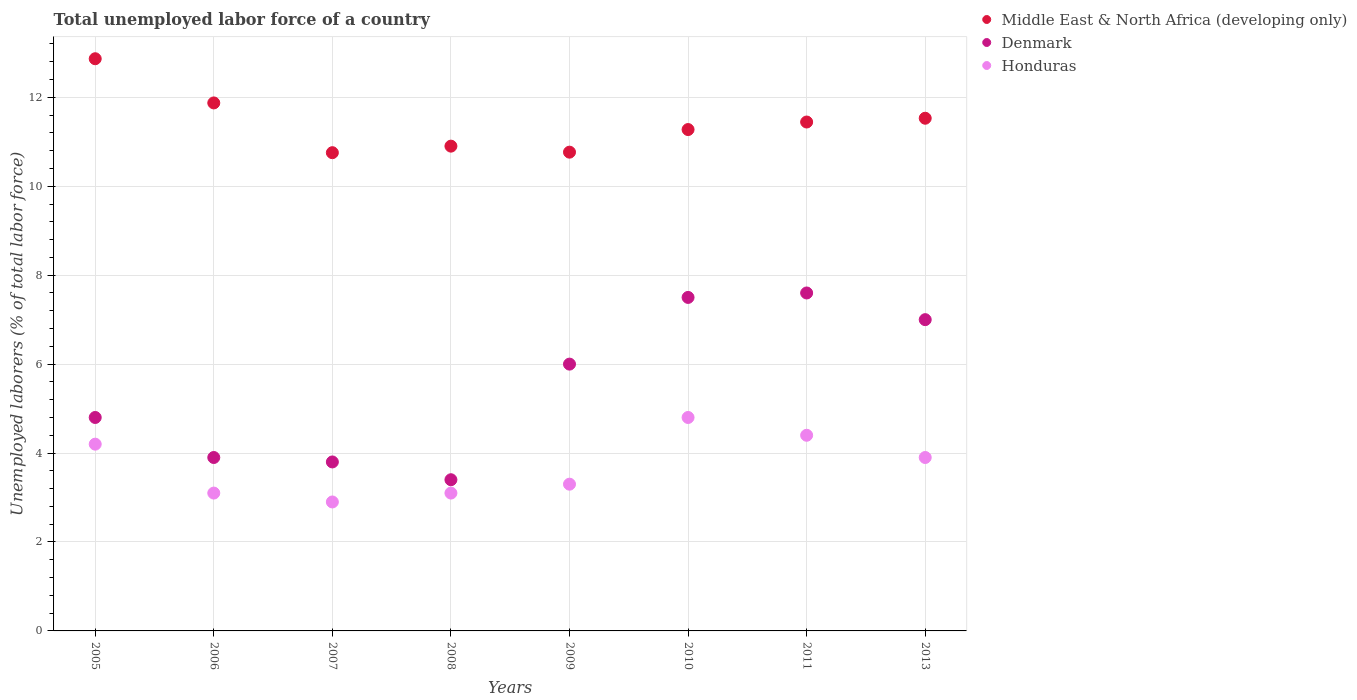What is the total unemployed labor force in Denmark in 2011?
Offer a very short reply. 7.6. Across all years, what is the maximum total unemployed labor force in Honduras?
Your answer should be very brief. 4.8. Across all years, what is the minimum total unemployed labor force in Denmark?
Your answer should be very brief. 3.4. In which year was the total unemployed labor force in Middle East & North Africa (developing only) maximum?
Keep it short and to the point. 2005. What is the total total unemployed labor force in Denmark in the graph?
Give a very brief answer. 44. What is the difference between the total unemployed labor force in Denmark in 2005 and that in 2009?
Your answer should be very brief. -1.2. What is the average total unemployed labor force in Honduras per year?
Provide a succinct answer. 3.71. In the year 2013, what is the difference between the total unemployed labor force in Middle East & North Africa (developing only) and total unemployed labor force in Honduras?
Offer a very short reply. 7.63. What is the ratio of the total unemployed labor force in Honduras in 2005 to that in 2008?
Your answer should be compact. 1.35. Is the total unemployed labor force in Middle East & North Africa (developing only) in 2007 less than that in 2011?
Provide a succinct answer. Yes. Is the difference between the total unemployed labor force in Middle East & North Africa (developing only) in 2007 and 2009 greater than the difference between the total unemployed labor force in Honduras in 2007 and 2009?
Offer a very short reply. Yes. What is the difference between the highest and the second highest total unemployed labor force in Denmark?
Offer a very short reply. 0.1. What is the difference between the highest and the lowest total unemployed labor force in Honduras?
Ensure brevity in your answer.  1.9. Is the total unemployed labor force in Honduras strictly greater than the total unemployed labor force in Middle East & North Africa (developing only) over the years?
Provide a succinct answer. No. How many years are there in the graph?
Keep it short and to the point. 8. What is the difference between two consecutive major ticks on the Y-axis?
Provide a short and direct response. 2. Does the graph contain any zero values?
Offer a very short reply. No. Does the graph contain grids?
Keep it short and to the point. Yes. Where does the legend appear in the graph?
Make the answer very short. Top right. What is the title of the graph?
Provide a short and direct response. Total unemployed labor force of a country. Does "Rwanda" appear as one of the legend labels in the graph?
Offer a very short reply. No. What is the label or title of the Y-axis?
Offer a terse response. Unemployed laborers (% of total labor force). What is the Unemployed laborers (% of total labor force) in Middle East & North Africa (developing only) in 2005?
Ensure brevity in your answer.  12.87. What is the Unemployed laborers (% of total labor force) in Denmark in 2005?
Keep it short and to the point. 4.8. What is the Unemployed laborers (% of total labor force) of Honduras in 2005?
Make the answer very short. 4.2. What is the Unemployed laborers (% of total labor force) of Middle East & North Africa (developing only) in 2006?
Offer a very short reply. 11.87. What is the Unemployed laborers (% of total labor force) of Denmark in 2006?
Provide a short and direct response. 3.9. What is the Unemployed laborers (% of total labor force) of Honduras in 2006?
Your response must be concise. 3.1. What is the Unemployed laborers (% of total labor force) in Middle East & North Africa (developing only) in 2007?
Make the answer very short. 10.75. What is the Unemployed laborers (% of total labor force) in Denmark in 2007?
Your response must be concise. 3.8. What is the Unemployed laborers (% of total labor force) in Honduras in 2007?
Your answer should be compact. 2.9. What is the Unemployed laborers (% of total labor force) of Middle East & North Africa (developing only) in 2008?
Your response must be concise. 10.9. What is the Unemployed laborers (% of total labor force) of Denmark in 2008?
Ensure brevity in your answer.  3.4. What is the Unemployed laborers (% of total labor force) of Honduras in 2008?
Your response must be concise. 3.1. What is the Unemployed laborers (% of total labor force) in Middle East & North Africa (developing only) in 2009?
Your answer should be compact. 10.77. What is the Unemployed laborers (% of total labor force) of Honduras in 2009?
Ensure brevity in your answer.  3.3. What is the Unemployed laborers (% of total labor force) of Middle East & North Africa (developing only) in 2010?
Your answer should be very brief. 11.28. What is the Unemployed laborers (% of total labor force) of Honduras in 2010?
Your answer should be compact. 4.8. What is the Unemployed laborers (% of total labor force) in Middle East & North Africa (developing only) in 2011?
Offer a terse response. 11.44. What is the Unemployed laborers (% of total labor force) of Denmark in 2011?
Provide a succinct answer. 7.6. What is the Unemployed laborers (% of total labor force) of Honduras in 2011?
Offer a terse response. 4.4. What is the Unemployed laborers (% of total labor force) of Middle East & North Africa (developing only) in 2013?
Offer a terse response. 11.53. What is the Unemployed laborers (% of total labor force) of Denmark in 2013?
Your response must be concise. 7. What is the Unemployed laborers (% of total labor force) of Honduras in 2013?
Your answer should be very brief. 3.9. Across all years, what is the maximum Unemployed laborers (% of total labor force) in Middle East & North Africa (developing only)?
Offer a very short reply. 12.87. Across all years, what is the maximum Unemployed laborers (% of total labor force) of Denmark?
Offer a terse response. 7.6. Across all years, what is the maximum Unemployed laborers (% of total labor force) in Honduras?
Your answer should be very brief. 4.8. Across all years, what is the minimum Unemployed laborers (% of total labor force) of Middle East & North Africa (developing only)?
Ensure brevity in your answer.  10.75. Across all years, what is the minimum Unemployed laborers (% of total labor force) in Denmark?
Provide a short and direct response. 3.4. Across all years, what is the minimum Unemployed laborers (% of total labor force) of Honduras?
Ensure brevity in your answer.  2.9. What is the total Unemployed laborers (% of total labor force) of Middle East & North Africa (developing only) in the graph?
Give a very brief answer. 91.41. What is the total Unemployed laborers (% of total labor force) in Honduras in the graph?
Give a very brief answer. 29.7. What is the difference between the Unemployed laborers (% of total labor force) of Middle East & North Africa (developing only) in 2005 and that in 2006?
Offer a very short reply. 0.99. What is the difference between the Unemployed laborers (% of total labor force) of Denmark in 2005 and that in 2006?
Provide a succinct answer. 0.9. What is the difference between the Unemployed laborers (% of total labor force) of Honduras in 2005 and that in 2006?
Your answer should be compact. 1.1. What is the difference between the Unemployed laborers (% of total labor force) of Middle East & North Africa (developing only) in 2005 and that in 2007?
Provide a short and direct response. 2.11. What is the difference between the Unemployed laborers (% of total labor force) in Middle East & North Africa (developing only) in 2005 and that in 2008?
Make the answer very short. 1.97. What is the difference between the Unemployed laborers (% of total labor force) in Denmark in 2005 and that in 2008?
Give a very brief answer. 1.4. What is the difference between the Unemployed laborers (% of total labor force) in Middle East & North Africa (developing only) in 2005 and that in 2009?
Ensure brevity in your answer.  2.1. What is the difference between the Unemployed laborers (% of total labor force) of Honduras in 2005 and that in 2009?
Your response must be concise. 0.9. What is the difference between the Unemployed laborers (% of total labor force) of Middle East & North Africa (developing only) in 2005 and that in 2010?
Ensure brevity in your answer.  1.59. What is the difference between the Unemployed laborers (% of total labor force) in Honduras in 2005 and that in 2010?
Your response must be concise. -0.6. What is the difference between the Unemployed laborers (% of total labor force) of Middle East & North Africa (developing only) in 2005 and that in 2011?
Keep it short and to the point. 1.42. What is the difference between the Unemployed laborers (% of total labor force) in Denmark in 2005 and that in 2011?
Offer a terse response. -2.8. What is the difference between the Unemployed laborers (% of total labor force) of Honduras in 2005 and that in 2011?
Your response must be concise. -0.2. What is the difference between the Unemployed laborers (% of total labor force) of Middle East & North Africa (developing only) in 2005 and that in 2013?
Make the answer very short. 1.34. What is the difference between the Unemployed laborers (% of total labor force) in Denmark in 2005 and that in 2013?
Keep it short and to the point. -2.2. What is the difference between the Unemployed laborers (% of total labor force) of Middle East & North Africa (developing only) in 2006 and that in 2007?
Ensure brevity in your answer.  1.12. What is the difference between the Unemployed laborers (% of total labor force) in Denmark in 2006 and that in 2007?
Make the answer very short. 0.1. What is the difference between the Unemployed laborers (% of total labor force) of Middle East & North Africa (developing only) in 2006 and that in 2008?
Offer a terse response. 0.97. What is the difference between the Unemployed laborers (% of total labor force) of Denmark in 2006 and that in 2008?
Your response must be concise. 0.5. What is the difference between the Unemployed laborers (% of total labor force) in Middle East & North Africa (developing only) in 2006 and that in 2009?
Offer a very short reply. 1.11. What is the difference between the Unemployed laborers (% of total labor force) of Middle East & North Africa (developing only) in 2006 and that in 2010?
Provide a short and direct response. 0.6. What is the difference between the Unemployed laborers (% of total labor force) of Denmark in 2006 and that in 2010?
Keep it short and to the point. -3.6. What is the difference between the Unemployed laborers (% of total labor force) in Middle East & North Africa (developing only) in 2006 and that in 2011?
Your answer should be compact. 0.43. What is the difference between the Unemployed laborers (% of total labor force) of Honduras in 2006 and that in 2011?
Keep it short and to the point. -1.3. What is the difference between the Unemployed laborers (% of total labor force) in Middle East & North Africa (developing only) in 2006 and that in 2013?
Your response must be concise. 0.34. What is the difference between the Unemployed laborers (% of total labor force) of Denmark in 2006 and that in 2013?
Ensure brevity in your answer.  -3.1. What is the difference between the Unemployed laborers (% of total labor force) in Honduras in 2006 and that in 2013?
Your answer should be very brief. -0.8. What is the difference between the Unemployed laborers (% of total labor force) of Middle East & North Africa (developing only) in 2007 and that in 2008?
Offer a very short reply. -0.15. What is the difference between the Unemployed laborers (% of total labor force) in Middle East & North Africa (developing only) in 2007 and that in 2009?
Give a very brief answer. -0.01. What is the difference between the Unemployed laborers (% of total labor force) in Denmark in 2007 and that in 2009?
Provide a succinct answer. -2.2. What is the difference between the Unemployed laborers (% of total labor force) of Honduras in 2007 and that in 2009?
Your answer should be very brief. -0.4. What is the difference between the Unemployed laborers (% of total labor force) of Middle East & North Africa (developing only) in 2007 and that in 2010?
Provide a succinct answer. -0.52. What is the difference between the Unemployed laborers (% of total labor force) in Denmark in 2007 and that in 2010?
Ensure brevity in your answer.  -3.7. What is the difference between the Unemployed laborers (% of total labor force) in Honduras in 2007 and that in 2010?
Make the answer very short. -1.9. What is the difference between the Unemployed laborers (% of total labor force) in Middle East & North Africa (developing only) in 2007 and that in 2011?
Offer a very short reply. -0.69. What is the difference between the Unemployed laborers (% of total labor force) in Denmark in 2007 and that in 2011?
Keep it short and to the point. -3.8. What is the difference between the Unemployed laborers (% of total labor force) of Middle East & North Africa (developing only) in 2007 and that in 2013?
Give a very brief answer. -0.77. What is the difference between the Unemployed laborers (% of total labor force) of Denmark in 2007 and that in 2013?
Offer a terse response. -3.2. What is the difference between the Unemployed laborers (% of total labor force) of Middle East & North Africa (developing only) in 2008 and that in 2009?
Keep it short and to the point. 0.14. What is the difference between the Unemployed laborers (% of total labor force) of Denmark in 2008 and that in 2009?
Provide a succinct answer. -2.6. What is the difference between the Unemployed laborers (% of total labor force) in Middle East & North Africa (developing only) in 2008 and that in 2010?
Offer a very short reply. -0.37. What is the difference between the Unemployed laborers (% of total labor force) in Honduras in 2008 and that in 2010?
Keep it short and to the point. -1.7. What is the difference between the Unemployed laborers (% of total labor force) of Middle East & North Africa (developing only) in 2008 and that in 2011?
Give a very brief answer. -0.54. What is the difference between the Unemployed laborers (% of total labor force) of Middle East & North Africa (developing only) in 2008 and that in 2013?
Provide a short and direct response. -0.63. What is the difference between the Unemployed laborers (% of total labor force) in Honduras in 2008 and that in 2013?
Your answer should be very brief. -0.8. What is the difference between the Unemployed laborers (% of total labor force) in Middle East & North Africa (developing only) in 2009 and that in 2010?
Offer a terse response. -0.51. What is the difference between the Unemployed laborers (% of total labor force) in Honduras in 2009 and that in 2010?
Offer a very short reply. -1.5. What is the difference between the Unemployed laborers (% of total labor force) of Middle East & North Africa (developing only) in 2009 and that in 2011?
Your response must be concise. -0.68. What is the difference between the Unemployed laborers (% of total labor force) of Honduras in 2009 and that in 2011?
Your answer should be compact. -1.1. What is the difference between the Unemployed laborers (% of total labor force) of Middle East & North Africa (developing only) in 2009 and that in 2013?
Offer a terse response. -0.76. What is the difference between the Unemployed laborers (% of total labor force) of Denmark in 2009 and that in 2013?
Your answer should be very brief. -1. What is the difference between the Unemployed laborers (% of total labor force) in Middle East & North Africa (developing only) in 2010 and that in 2011?
Give a very brief answer. -0.17. What is the difference between the Unemployed laborers (% of total labor force) of Middle East & North Africa (developing only) in 2010 and that in 2013?
Give a very brief answer. -0.25. What is the difference between the Unemployed laborers (% of total labor force) of Middle East & North Africa (developing only) in 2011 and that in 2013?
Your answer should be compact. -0.09. What is the difference between the Unemployed laborers (% of total labor force) of Middle East & North Africa (developing only) in 2005 and the Unemployed laborers (% of total labor force) of Denmark in 2006?
Your response must be concise. 8.97. What is the difference between the Unemployed laborers (% of total labor force) of Middle East & North Africa (developing only) in 2005 and the Unemployed laborers (% of total labor force) of Honduras in 2006?
Offer a very short reply. 9.77. What is the difference between the Unemployed laborers (% of total labor force) of Middle East & North Africa (developing only) in 2005 and the Unemployed laborers (% of total labor force) of Denmark in 2007?
Provide a succinct answer. 9.07. What is the difference between the Unemployed laborers (% of total labor force) of Middle East & North Africa (developing only) in 2005 and the Unemployed laborers (% of total labor force) of Honduras in 2007?
Offer a very short reply. 9.97. What is the difference between the Unemployed laborers (% of total labor force) of Middle East & North Africa (developing only) in 2005 and the Unemployed laborers (% of total labor force) of Denmark in 2008?
Offer a very short reply. 9.47. What is the difference between the Unemployed laborers (% of total labor force) in Middle East & North Africa (developing only) in 2005 and the Unemployed laborers (% of total labor force) in Honduras in 2008?
Offer a terse response. 9.77. What is the difference between the Unemployed laborers (% of total labor force) of Denmark in 2005 and the Unemployed laborers (% of total labor force) of Honduras in 2008?
Your answer should be compact. 1.7. What is the difference between the Unemployed laborers (% of total labor force) of Middle East & North Africa (developing only) in 2005 and the Unemployed laborers (% of total labor force) of Denmark in 2009?
Your answer should be very brief. 6.87. What is the difference between the Unemployed laborers (% of total labor force) in Middle East & North Africa (developing only) in 2005 and the Unemployed laborers (% of total labor force) in Honduras in 2009?
Give a very brief answer. 9.57. What is the difference between the Unemployed laborers (% of total labor force) in Denmark in 2005 and the Unemployed laborers (% of total labor force) in Honduras in 2009?
Your answer should be compact. 1.5. What is the difference between the Unemployed laborers (% of total labor force) of Middle East & North Africa (developing only) in 2005 and the Unemployed laborers (% of total labor force) of Denmark in 2010?
Give a very brief answer. 5.37. What is the difference between the Unemployed laborers (% of total labor force) in Middle East & North Africa (developing only) in 2005 and the Unemployed laborers (% of total labor force) in Honduras in 2010?
Provide a short and direct response. 8.07. What is the difference between the Unemployed laborers (% of total labor force) of Middle East & North Africa (developing only) in 2005 and the Unemployed laborers (% of total labor force) of Denmark in 2011?
Your answer should be very brief. 5.27. What is the difference between the Unemployed laborers (% of total labor force) of Middle East & North Africa (developing only) in 2005 and the Unemployed laborers (% of total labor force) of Honduras in 2011?
Keep it short and to the point. 8.47. What is the difference between the Unemployed laborers (% of total labor force) in Middle East & North Africa (developing only) in 2005 and the Unemployed laborers (% of total labor force) in Denmark in 2013?
Make the answer very short. 5.87. What is the difference between the Unemployed laborers (% of total labor force) in Middle East & North Africa (developing only) in 2005 and the Unemployed laborers (% of total labor force) in Honduras in 2013?
Your answer should be compact. 8.97. What is the difference between the Unemployed laborers (% of total labor force) of Denmark in 2005 and the Unemployed laborers (% of total labor force) of Honduras in 2013?
Keep it short and to the point. 0.9. What is the difference between the Unemployed laborers (% of total labor force) in Middle East & North Africa (developing only) in 2006 and the Unemployed laborers (% of total labor force) in Denmark in 2007?
Provide a short and direct response. 8.07. What is the difference between the Unemployed laborers (% of total labor force) in Middle East & North Africa (developing only) in 2006 and the Unemployed laborers (% of total labor force) in Honduras in 2007?
Your response must be concise. 8.97. What is the difference between the Unemployed laborers (% of total labor force) of Denmark in 2006 and the Unemployed laborers (% of total labor force) of Honduras in 2007?
Provide a succinct answer. 1. What is the difference between the Unemployed laborers (% of total labor force) of Middle East & North Africa (developing only) in 2006 and the Unemployed laborers (% of total labor force) of Denmark in 2008?
Provide a succinct answer. 8.47. What is the difference between the Unemployed laborers (% of total labor force) in Middle East & North Africa (developing only) in 2006 and the Unemployed laborers (% of total labor force) in Honduras in 2008?
Make the answer very short. 8.77. What is the difference between the Unemployed laborers (% of total labor force) in Denmark in 2006 and the Unemployed laborers (% of total labor force) in Honduras in 2008?
Ensure brevity in your answer.  0.8. What is the difference between the Unemployed laborers (% of total labor force) in Middle East & North Africa (developing only) in 2006 and the Unemployed laborers (% of total labor force) in Denmark in 2009?
Keep it short and to the point. 5.87. What is the difference between the Unemployed laborers (% of total labor force) of Middle East & North Africa (developing only) in 2006 and the Unemployed laborers (% of total labor force) of Honduras in 2009?
Your answer should be very brief. 8.57. What is the difference between the Unemployed laborers (% of total labor force) of Denmark in 2006 and the Unemployed laborers (% of total labor force) of Honduras in 2009?
Give a very brief answer. 0.6. What is the difference between the Unemployed laborers (% of total labor force) in Middle East & North Africa (developing only) in 2006 and the Unemployed laborers (% of total labor force) in Denmark in 2010?
Ensure brevity in your answer.  4.37. What is the difference between the Unemployed laborers (% of total labor force) of Middle East & North Africa (developing only) in 2006 and the Unemployed laborers (% of total labor force) of Honduras in 2010?
Keep it short and to the point. 7.07. What is the difference between the Unemployed laborers (% of total labor force) of Denmark in 2006 and the Unemployed laborers (% of total labor force) of Honduras in 2010?
Ensure brevity in your answer.  -0.9. What is the difference between the Unemployed laborers (% of total labor force) in Middle East & North Africa (developing only) in 2006 and the Unemployed laborers (% of total labor force) in Denmark in 2011?
Your answer should be very brief. 4.27. What is the difference between the Unemployed laborers (% of total labor force) of Middle East & North Africa (developing only) in 2006 and the Unemployed laborers (% of total labor force) of Honduras in 2011?
Keep it short and to the point. 7.47. What is the difference between the Unemployed laborers (% of total labor force) in Denmark in 2006 and the Unemployed laborers (% of total labor force) in Honduras in 2011?
Make the answer very short. -0.5. What is the difference between the Unemployed laborers (% of total labor force) in Middle East & North Africa (developing only) in 2006 and the Unemployed laborers (% of total labor force) in Denmark in 2013?
Ensure brevity in your answer.  4.87. What is the difference between the Unemployed laborers (% of total labor force) in Middle East & North Africa (developing only) in 2006 and the Unemployed laborers (% of total labor force) in Honduras in 2013?
Your response must be concise. 7.97. What is the difference between the Unemployed laborers (% of total labor force) of Denmark in 2006 and the Unemployed laborers (% of total labor force) of Honduras in 2013?
Keep it short and to the point. 0. What is the difference between the Unemployed laborers (% of total labor force) in Middle East & North Africa (developing only) in 2007 and the Unemployed laborers (% of total labor force) in Denmark in 2008?
Provide a succinct answer. 7.35. What is the difference between the Unemployed laborers (% of total labor force) in Middle East & North Africa (developing only) in 2007 and the Unemployed laborers (% of total labor force) in Honduras in 2008?
Make the answer very short. 7.65. What is the difference between the Unemployed laborers (% of total labor force) in Denmark in 2007 and the Unemployed laborers (% of total labor force) in Honduras in 2008?
Ensure brevity in your answer.  0.7. What is the difference between the Unemployed laborers (% of total labor force) of Middle East & North Africa (developing only) in 2007 and the Unemployed laborers (% of total labor force) of Denmark in 2009?
Your answer should be very brief. 4.75. What is the difference between the Unemployed laborers (% of total labor force) of Middle East & North Africa (developing only) in 2007 and the Unemployed laborers (% of total labor force) of Honduras in 2009?
Your response must be concise. 7.45. What is the difference between the Unemployed laborers (% of total labor force) of Denmark in 2007 and the Unemployed laborers (% of total labor force) of Honduras in 2009?
Offer a very short reply. 0.5. What is the difference between the Unemployed laborers (% of total labor force) of Middle East & North Africa (developing only) in 2007 and the Unemployed laborers (% of total labor force) of Denmark in 2010?
Provide a short and direct response. 3.25. What is the difference between the Unemployed laborers (% of total labor force) in Middle East & North Africa (developing only) in 2007 and the Unemployed laborers (% of total labor force) in Honduras in 2010?
Give a very brief answer. 5.95. What is the difference between the Unemployed laborers (% of total labor force) in Denmark in 2007 and the Unemployed laborers (% of total labor force) in Honduras in 2010?
Your answer should be compact. -1. What is the difference between the Unemployed laborers (% of total labor force) of Middle East & North Africa (developing only) in 2007 and the Unemployed laborers (% of total labor force) of Denmark in 2011?
Your answer should be very brief. 3.15. What is the difference between the Unemployed laborers (% of total labor force) in Middle East & North Africa (developing only) in 2007 and the Unemployed laborers (% of total labor force) in Honduras in 2011?
Keep it short and to the point. 6.35. What is the difference between the Unemployed laborers (% of total labor force) in Denmark in 2007 and the Unemployed laborers (% of total labor force) in Honduras in 2011?
Offer a terse response. -0.6. What is the difference between the Unemployed laborers (% of total labor force) in Middle East & North Africa (developing only) in 2007 and the Unemployed laborers (% of total labor force) in Denmark in 2013?
Your answer should be compact. 3.75. What is the difference between the Unemployed laborers (% of total labor force) in Middle East & North Africa (developing only) in 2007 and the Unemployed laborers (% of total labor force) in Honduras in 2013?
Provide a short and direct response. 6.85. What is the difference between the Unemployed laborers (% of total labor force) in Middle East & North Africa (developing only) in 2008 and the Unemployed laborers (% of total labor force) in Denmark in 2009?
Your answer should be very brief. 4.9. What is the difference between the Unemployed laborers (% of total labor force) in Middle East & North Africa (developing only) in 2008 and the Unemployed laborers (% of total labor force) in Honduras in 2009?
Offer a very short reply. 7.6. What is the difference between the Unemployed laborers (% of total labor force) in Middle East & North Africa (developing only) in 2008 and the Unemployed laborers (% of total labor force) in Denmark in 2010?
Make the answer very short. 3.4. What is the difference between the Unemployed laborers (% of total labor force) in Middle East & North Africa (developing only) in 2008 and the Unemployed laborers (% of total labor force) in Honduras in 2010?
Your answer should be compact. 6.1. What is the difference between the Unemployed laborers (% of total labor force) in Denmark in 2008 and the Unemployed laborers (% of total labor force) in Honduras in 2010?
Offer a very short reply. -1.4. What is the difference between the Unemployed laborers (% of total labor force) in Middle East & North Africa (developing only) in 2008 and the Unemployed laborers (% of total labor force) in Denmark in 2011?
Your answer should be very brief. 3.3. What is the difference between the Unemployed laborers (% of total labor force) in Middle East & North Africa (developing only) in 2008 and the Unemployed laborers (% of total labor force) in Honduras in 2011?
Give a very brief answer. 6.5. What is the difference between the Unemployed laborers (% of total labor force) of Middle East & North Africa (developing only) in 2008 and the Unemployed laborers (% of total labor force) of Denmark in 2013?
Offer a very short reply. 3.9. What is the difference between the Unemployed laborers (% of total labor force) of Middle East & North Africa (developing only) in 2008 and the Unemployed laborers (% of total labor force) of Honduras in 2013?
Offer a very short reply. 7. What is the difference between the Unemployed laborers (% of total labor force) of Denmark in 2008 and the Unemployed laborers (% of total labor force) of Honduras in 2013?
Your response must be concise. -0.5. What is the difference between the Unemployed laborers (% of total labor force) of Middle East & North Africa (developing only) in 2009 and the Unemployed laborers (% of total labor force) of Denmark in 2010?
Offer a very short reply. 3.27. What is the difference between the Unemployed laborers (% of total labor force) in Middle East & North Africa (developing only) in 2009 and the Unemployed laborers (% of total labor force) in Honduras in 2010?
Your response must be concise. 5.97. What is the difference between the Unemployed laborers (% of total labor force) in Denmark in 2009 and the Unemployed laborers (% of total labor force) in Honduras in 2010?
Keep it short and to the point. 1.2. What is the difference between the Unemployed laborers (% of total labor force) of Middle East & North Africa (developing only) in 2009 and the Unemployed laborers (% of total labor force) of Denmark in 2011?
Give a very brief answer. 3.17. What is the difference between the Unemployed laborers (% of total labor force) of Middle East & North Africa (developing only) in 2009 and the Unemployed laborers (% of total labor force) of Honduras in 2011?
Provide a succinct answer. 6.37. What is the difference between the Unemployed laborers (% of total labor force) of Middle East & North Africa (developing only) in 2009 and the Unemployed laborers (% of total labor force) of Denmark in 2013?
Make the answer very short. 3.77. What is the difference between the Unemployed laborers (% of total labor force) in Middle East & North Africa (developing only) in 2009 and the Unemployed laborers (% of total labor force) in Honduras in 2013?
Your answer should be compact. 6.87. What is the difference between the Unemployed laborers (% of total labor force) of Middle East & North Africa (developing only) in 2010 and the Unemployed laborers (% of total labor force) of Denmark in 2011?
Make the answer very short. 3.68. What is the difference between the Unemployed laborers (% of total labor force) of Middle East & North Africa (developing only) in 2010 and the Unemployed laborers (% of total labor force) of Honduras in 2011?
Provide a succinct answer. 6.88. What is the difference between the Unemployed laborers (% of total labor force) in Denmark in 2010 and the Unemployed laborers (% of total labor force) in Honduras in 2011?
Offer a terse response. 3.1. What is the difference between the Unemployed laborers (% of total labor force) of Middle East & North Africa (developing only) in 2010 and the Unemployed laborers (% of total labor force) of Denmark in 2013?
Keep it short and to the point. 4.28. What is the difference between the Unemployed laborers (% of total labor force) of Middle East & North Africa (developing only) in 2010 and the Unemployed laborers (% of total labor force) of Honduras in 2013?
Give a very brief answer. 7.38. What is the difference between the Unemployed laborers (% of total labor force) of Middle East & North Africa (developing only) in 2011 and the Unemployed laborers (% of total labor force) of Denmark in 2013?
Keep it short and to the point. 4.44. What is the difference between the Unemployed laborers (% of total labor force) in Middle East & North Africa (developing only) in 2011 and the Unemployed laborers (% of total labor force) in Honduras in 2013?
Give a very brief answer. 7.54. What is the average Unemployed laborers (% of total labor force) of Middle East & North Africa (developing only) per year?
Your answer should be compact. 11.43. What is the average Unemployed laborers (% of total labor force) of Denmark per year?
Give a very brief answer. 5.5. What is the average Unemployed laborers (% of total labor force) of Honduras per year?
Provide a succinct answer. 3.71. In the year 2005, what is the difference between the Unemployed laborers (% of total labor force) in Middle East & North Africa (developing only) and Unemployed laborers (% of total labor force) in Denmark?
Your response must be concise. 8.07. In the year 2005, what is the difference between the Unemployed laborers (% of total labor force) of Middle East & North Africa (developing only) and Unemployed laborers (% of total labor force) of Honduras?
Keep it short and to the point. 8.67. In the year 2005, what is the difference between the Unemployed laborers (% of total labor force) in Denmark and Unemployed laborers (% of total labor force) in Honduras?
Your answer should be compact. 0.6. In the year 2006, what is the difference between the Unemployed laborers (% of total labor force) of Middle East & North Africa (developing only) and Unemployed laborers (% of total labor force) of Denmark?
Your answer should be very brief. 7.97. In the year 2006, what is the difference between the Unemployed laborers (% of total labor force) of Middle East & North Africa (developing only) and Unemployed laborers (% of total labor force) of Honduras?
Offer a very short reply. 8.77. In the year 2006, what is the difference between the Unemployed laborers (% of total labor force) of Denmark and Unemployed laborers (% of total labor force) of Honduras?
Offer a terse response. 0.8. In the year 2007, what is the difference between the Unemployed laborers (% of total labor force) in Middle East & North Africa (developing only) and Unemployed laborers (% of total labor force) in Denmark?
Offer a very short reply. 6.95. In the year 2007, what is the difference between the Unemployed laborers (% of total labor force) in Middle East & North Africa (developing only) and Unemployed laborers (% of total labor force) in Honduras?
Your answer should be compact. 7.85. In the year 2007, what is the difference between the Unemployed laborers (% of total labor force) in Denmark and Unemployed laborers (% of total labor force) in Honduras?
Keep it short and to the point. 0.9. In the year 2008, what is the difference between the Unemployed laborers (% of total labor force) of Middle East & North Africa (developing only) and Unemployed laborers (% of total labor force) of Denmark?
Give a very brief answer. 7.5. In the year 2008, what is the difference between the Unemployed laborers (% of total labor force) of Middle East & North Africa (developing only) and Unemployed laborers (% of total labor force) of Honduras?
Keep it short and to the point. 7.8. In the year 2009, what is the difference between the Unemployed laborers (% of total labor force) in Middle East & North Africa (developing only) and Unemployed laborers (% of total labor force) in Denmark?
Your response must be concise. 4.77. In the year 2009, what is the difference between the Unemployed laborers (% of total labor force) in Middle East & North Africa (developing only) and Unemployed laborers (% of total labor force) in Honduras?
Provide a short and direct response. 7.47. In the year 2010, what is the difference between the Unemployed laborers (% of total labor force) in Middle East & North Africa (developing only) and Unemployed laborers (% of total labor force) in Denmark?
Your answer should be compact. 3.78. In the year 2010, what is the difference between the Unemployed laborers (% of total labor force) of Middle East & North Africa (developing only) and Unemployed laborers (% of total labor force) of Honduras?
Provide a short and direct response. 6.48. In the year 2011, what is the difference between the Unemployed laborers (% of total labor force) of Middle East & North Africa (developing only) and Unemployed laborers (% of total labor force) of Denmark?
Keep it short and to the point. 3.84. In the year 2011, what is the difference between the Unemployed laborers (% of total labor force) in Middle East & North Africa (developing only) and Unemployed laborers (% of total labor force) in Honduras?
Offer a very short reply. 7.04. In the year 2011, what is the difference between the Unemployed laborers (% of total labor force) in Denmark and Unemployed laborers (% of total labor force) in Honduras?
Provide a short and direct response. 3.2. In the year 2013, what is the difference between the Unemployed laborers (% of total labor force) in Middle East & North Africa (developing only) and Unemployed laborers (% of total labor force) in Denmark?
Make the answer very short. 4.53. In the year 2013, what is the difference between the Unemployed laborers (% of total labor force) in Middle East & North Africa (developing only) and Unemployed laborers (% of total labor force) in Honduras?
Provide a short and direct response. 7.63. What is the ratio of the Unemployed laborers (% of total labor force) of Middle East & North Africa (developing only) in 2005 to that in 2006?
Ensure brevity in your answer.  1.08. What is the ratio of the Unemployed laborers (% of total labor force) in Denmark in 2005 to that in 2006?
Offer a very short reply. 1.23. What is the ratio of the Unemployed laborers (% of total labor force) in Honduras in 2005 to that in 2006?
Your response must be concise. 1.35. What is the ratio of the Unemployed laborers (% of total labor force) of Middle East & North Africa (developing only) in 2005 to that in 2007?
Give a very brief answer. 1.2. What is the ratio of the Unemployed laborers (% of total labor force) of Denmark in 2005 to that in 2007?
Make the answer very short. 1.26. What is the ratio of the Unemployed laborers (% of total labor force) of Honduras in 2005 to that in 2007?
Your answer should be compact. 1.45. What is the ratio of the Unemployed laborers (% of total labor force) in Middle East & North Africa (developing only) in 2005 to that in 2008?
Make the answer very short. 1.18. What is the ratio of the Unemployed laborers (% of total labor force) of Denmark in 2005 to that in 2008?
Your answer should be very brief. 1.41. What is the ratio of the Unemployed laborers (% of total labor force) in Honduras in 2005 to that in 2008?
Your response must be concise. 1.35. What is the ratio of the Unemployed laborers (% of total labor force) in Middle East & North Africa (developing only) in 2005 to that in 2009?
Give a very brief answer. 1.2. What is the ratio of the Unemployed laborers (% of total labor force) in Denmark in 2005 to that in 2009?
Your response must be concise. 0.8. What is the ratio of the Unemployed laborers (% of total labor force) of Honduras in 2005 to that in 2009?
Offer a very short reply. 1.27. What is the ratio of the Unemployed laborers (% of total labor force) of Middle East & North Africa (developing only) in 2005 to that in 2010?
Keep it short and to the point. 1.14. What is the ratio of the Unemployed laborers (% of total labor force) of Denmark in 2005 to that in 2010?
Your response must be concise. 0.64. What is the ratio of the Unemployed laborers (% of total labor force) of Middle East & North Africa (developing only) in 2005 to that in 2011?
Ensure brevity in your answer.  1.12. What is the ratio of the Unemployed laborers (% of total labor force) in Denmark in 2005 to that in 2011?
Your answer should be very brief. 0.63. What is the ratio of the Unemployed laborers (% of total labor force) in Honduras in 2005 to that in 2011?
Your answer should be compact. 0.95. What is the ratio of the Unemployed laborers (% of total labor force) of Middle East & North Africa (developing only) in 2005 to that in 2013?
Your answer should be compact. 1.12. What is the ratio of the Unemployed laborers (% of total labor force) of Denmark in 2005 to that in 2013?
Provide a succinct answer. 0.69. What is the ratio of the Unemployed laborers (% of total labor force) of Honduras in 2005 to that in 2013?
Give a very brief answer. 1.08. What is the ratio of the Unemployed laborers (% of total labor force) in Middle East & North Africa (developing only) in 2006 to that in 2007?
Your answer should be very brief. 1.1. What is the ratio of the Unemployed laborers (% of total labor force) of Denmark in 2006 to that in 2007?
Provide a short and direct response. 1.03. What is the ratio of the Unemployed laborers (% of total labor force) in Honduras in 2006 to that in 2007?
Make the answer very short. 1.07. What is the ratio of the Unemployed laborers (% of total labor force) in Middle East & North Africa (developing only) in 2006 to that in 2008?
Give a very brief answer. 1.09. What is the ratio of the Unemployed laborers (% of total labor force) of Denmark in 2006 to that in 2008?
Offer a very short reply. 1.15. What is the ratio of the Unemployed laborers (% of total labor force) in Middle East & North Africa (developing only) in 2006 to that in 2009?
Keep it short and to the point. 1.1. What is the ratio of the Unemployed laborers (% of total labor force) of Denmark in 2006 to that in 2009?
Give a very brief answer. 0.65. What is the ratio of the Unemployed laborers (% of total labor force) in Honduras in 2006 to that in 2009?
Offer a terse response. 0.94. What is the ratio of the Unemployed laborers (% of total labor force) of Middle East & North Africa (developing only) in 2006 to that in 2010?
Ensure brevity in your answer.  1.05. What is the ratio of the Unemployed laborers (% of total labor force) in Denmark in 2006 to that in 2010?
Give a very brief answer. 0.52. What is the ratio of the Unemployed laborers (% of total labor force) in Honduras in 2006 to that in 2010?
Give a very brief answer. 0.65. What is the ratio of the Unemployed laborers (% of total labor force) in Middle East & North Africa (developing only) in 2006 to that in 2011?
Your answer should be compact. 1.04. What is the ratio of the Unemployed laborers (% of total labor force) of Denmark in 2006 to that in 2011?
Provide a short and direct response. 0.51. What is the ratio of the Unemployed laborers (% of total labor force) in Honduras in 2006 to that in 2011?
Provide a short and direct response. 0.7. What is the ratio of the Unemployed laborers (% of total labor force) in Middle East & North Africa (developing only) in 2006 to that in 2013?
Keep it short and to the point. 1.03. What is the ratio of the Unemployed laborers (% of total labor force) of Denmark in 2006 to that in 2013?
Keep it short and to the point. 0.56. What is the ratio of the Unemployed laborers (% of total labor force) in Honduras in 2006 to that in 2013?
Ensure brevity in your answer.  0.79. What is the ratio of the Unemployed laborers (% of total labor force) of Middle East & North Africa (developing only) in 2007 to that in 2008?
Give a very brief answer. 0.99. What is the ratio of the Unemployed laborers (% of total labor force) in Denmark in 2007 to that in 2008?
Your response must be concise. 1.12. What is the ratio of the Unemployed laborers (% of total labor force) of Honduras in 2007 to that in 2008?
Provide a short and direct response. 0.94. What is the ratio of the Unemployed laborers (% of total labor force) in Middle East & North Africa (developing only) in 2007 to that in 2009?
Your answer should be compact. 1. What is the ratio of the Unemployed laborers (% of total labor force) of Denmark in 2007 to that in 2009?
Provide a succinct answer. 0.63. What is the ratio of the Unemployed laborers (% of total labor force) of Honduras in 2007 to that in 2009?
Offer a very short reply. 0.88. What is the ratio of the Unemployed laborers (% of total labor force) of Middle East & North Africa (developing only) in 2007 to that in 2010?
Make the answer very short. 0.95. What is the ratio of the Unemployed laborers (% of total labor force) of Denmark in 2007 to that in 2010?
Offer a terse response. 0.51. What is the ratio of the Unemployed laborers (% of total labor force) in Honduras in 2007 to that in 2010?
Make the answer very short. 0.6. What is the ratio of the Unemployed laborers (% of total labor force) in Middle East & North Africa (developing only) in 2007 to that in 2011?
Your answer should be compact. 0.94. What is the ratio of the Unemployed laborers (% of total labor force) of Honduras in 2007 to that in 2011?
Offer a very short reply. 0.66. What is the ratio of the Unemployed laborers (% of total labor force) in Middle East & North Africa (developing only) in 2007 to that in 2013?
Make the answer very short. 0.93. What is the ratio of the Unemployed laborers (% of total labor force) of Denmark in 2007 to that in 2013?
Ensure brevity in your answer.  0.54. What is the ratio of the Unemployed laborers (% of total labor force) in Honduras in 2007 to that in 2013?
Offer a terse response. 0.74. What is the ratio of the Unemployed laborers (% of total labor force) in Middle East & North Africa (developing only) in 2008 to that in 2009?
Keep it short and to the point. 1.01. What is the ratio of the Unemployed laborers (% of total labor force) of Denmark in 2008 to that in 2009?
Make the answer very short. 0.57. What is the ratio of the Unemployed laborers (% of total labor force) of Honduras in 2008 to that in 2009?
Ensure brevity in your answer.  0.94. What is the ratio of the Unemployed laborers (% of total labor force) of Middle East & North Africa (developing only) in 2008 to that in 2010?
Your answer should be very brief. 0.97. What is the ratio of the Unemployed laborers (% of total labor force) of Denmark in 2008 to that in 2010?
Make the answer very short. 0.45. What is the ratio of the Unemployed laborers (% of total labor force) of Honduras in 2008 to that in 2010?
Make the answer very short. 0.65. What is the ratio of the Unemployed laborers (% of total labor force) of Middle East & North Africa (developing only) in 2008 to that in 2011?
Provide a short and direct response. 0.95. What is the ratio of the Unemployed laborers (% of total labor force) of Denmark in 2008 to that in 2011?
Your answer should be compact. 0.45. What is the ratio of the Unemployed laborers (% of total labor force) in Honduras in 2008 to that in 2011?
Provide a short and direct response. 0.7. What is the ratio of the Unemployed laborers (% of total labor force) in Middle East & North Africa (developing only) in 2008 to that in 2013?
Offer a very short reply. 0.95. What is the ratio of the Unemployed laborers (% of total labor force) of Denmark in 2008 to that in 2013?
Your answer should be very brief. 0.49. What is the ratio of the Unemployed laborers (% of total labor force) of Honduras in 2008 to that in 2013?
Give a very brief answer. 0.79. What is the ratio of the Unemployed laborers (% of total labor force) in Middle East & North Africa (developing only) in 2009 to that in 2010?
Offer a terse response. 0.95. What is the ratio of the Unemployed laborers (% of total labor force) in Denmark in 2009 to that in 2010?
Your response must be concise. 0.8. What is the ratio of the Unemployed laborers (% of total labor force) of Honduras in 2009 to that in 2010?
Your response must be concise. 0.69. What is the ratio of the Unemployed laborers (% of total labor force) in Middle East & North Africa (developing only) in 2009 to that in 2011?
Provide a succinct answer. 0.94. What is the ratio of the Unemployed laborers (% of total labor force) of Denmark in 2009 to that in 2011?
Provide a short and direct response. 0.79. What is the ratio of the Unemployed laborers (% of total labor force) of Honduras in 2009 to that in 2011?
Ensure brevity in your answer.  0.75. What is the ratio of the Unemployed laborers (% of total labor force) in Middle East & North Africa (developing only) in 2009 to that in 2013?
Make the answer very short. 0.93. What is the ratio of the Unemployed laborers (% of total labor force) in Denmark in 2009 to that in 2013?
Your answer should be compact. 0.86. What is the ratio of the Unemployed laborers (% of total labor force) in Honduras in 2009 to that in 2013?
Your answer should be very brief. 0.85. What is the ratio of the Unemployed laborers (% of total labor force) in Middle East & North Africa (developing only) in 2010 to that in 2011?
Give a very brief answer. 0.99. What is the ratio of the Unemployed laborers (% of total labor force) in Honduras in 2010 to that in 2011?
Your answer should be compact. 1.09. What is the ratio of the Unemployed laborers (% of total labor force) in Middle East & North Africa (developing only) in 2010 to that in 2013?
Your answer should be very brief. 0.98. What is the ratio of the Unemployed laborers (% of total labor force) in Denmark in 2010 to that in 2013?
Provide a succinct answer. 1.07. What is the ratio of the Unemployed laborers (% of total labor force) of Honduras in 2010 to that in 2013?
Make the answer very short. 1.23. What is the ratio of the Unemployed laborers (% of total labor force) of Middle East & North Africa (developing only) in 2011 to that in 2013?
Ensure brevity in your answer.  0.99. What is the ratio of the Unemployed laborers (% of total labor force) of Denmark in 2011 to that in 2013?
Your response must be concise. 1.09. What is the ratio of the Unemployed laborers (% of total labor force) of Honduras in 2011 to that in 2013?
Your response must be concise. 1.13. What is the difference between the highest and the second highest Unemployed laborers (% of total labor force) of Middle East & North Africa (developing only)?
Offer a terse response. 0.99. What is the difference between the highest and the second highest Unemployed laborers (% of total labor force) in Denmark?
Your response must be concise. 0.1. What is the difference between the highest and the lowest Unemployed laborers (% of total labor force) of Middle East & North Africa (developing only)?
Your answer should be compact. 2.11. What is the difference between the highest and the lowest Unemployed laborers (% of total labor force) in Honduras?
Offer a terse response. 1.9. 